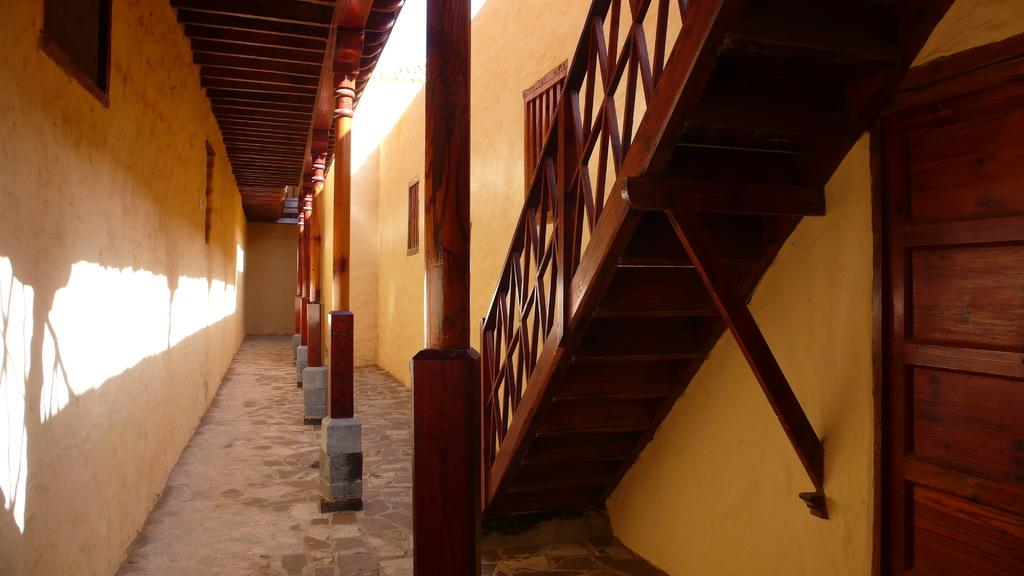What type of material is used for the pillars in the image? The wooden pillars are visible in the image. What structure surrounds the pillars? There is a wall surrounding the pillars. What can be seen on the right side of the image? There are wooden stairs on the right side of the image. What is located beside the stairs? There is a door beside the stairs. What color is the marble eye in the image? There is no marble eye present in the image; it only features wooden pillars, a wall, wooden stairs, and a door. 